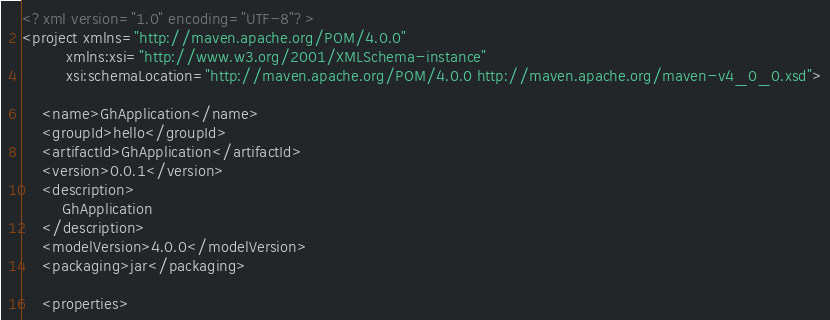<code> <loc_0><loc_0><loc_500><loc_500><_XML_><?xml version="1.0" encoding="UTF-8"?>
<project xmlns="http://maven.apache.org/POM/4.0.0"
         xmlns:xsi="http://www.w3.org/2001/XMLSchema-instance"
         xsi:schemaLocation="http://maven.apache.org/POM/4.0.0 http://maven.apache.org/maven-v4_0_0.xsd">

    <name>GhApplication</name>
    <groupId>hello</groupId>
    <artifactId>GhApplication</artifactId>
    <version>0.0.1</version>
    <description>
        GhApplication
    </description>
    <modelVersion>4.0.0</modelVersion>
    <packaging>jar</packaging>

    <properties></code> 